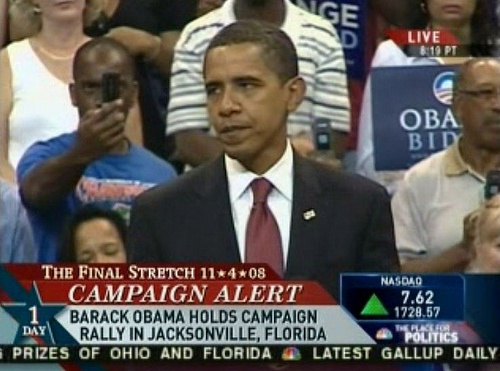Describe the objects in this image and their specific colors. I can see people in gray, black, and white tones, people in gray, black, and maroon tones, people in gray, darkgray, and black tones, people in gray, beige, darkgray, and black tones, and people in gray, white, and tan tones in this image. 